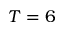<formula> <loc_0><loc_0><loc_500><loc_500>T = 6</formula> 